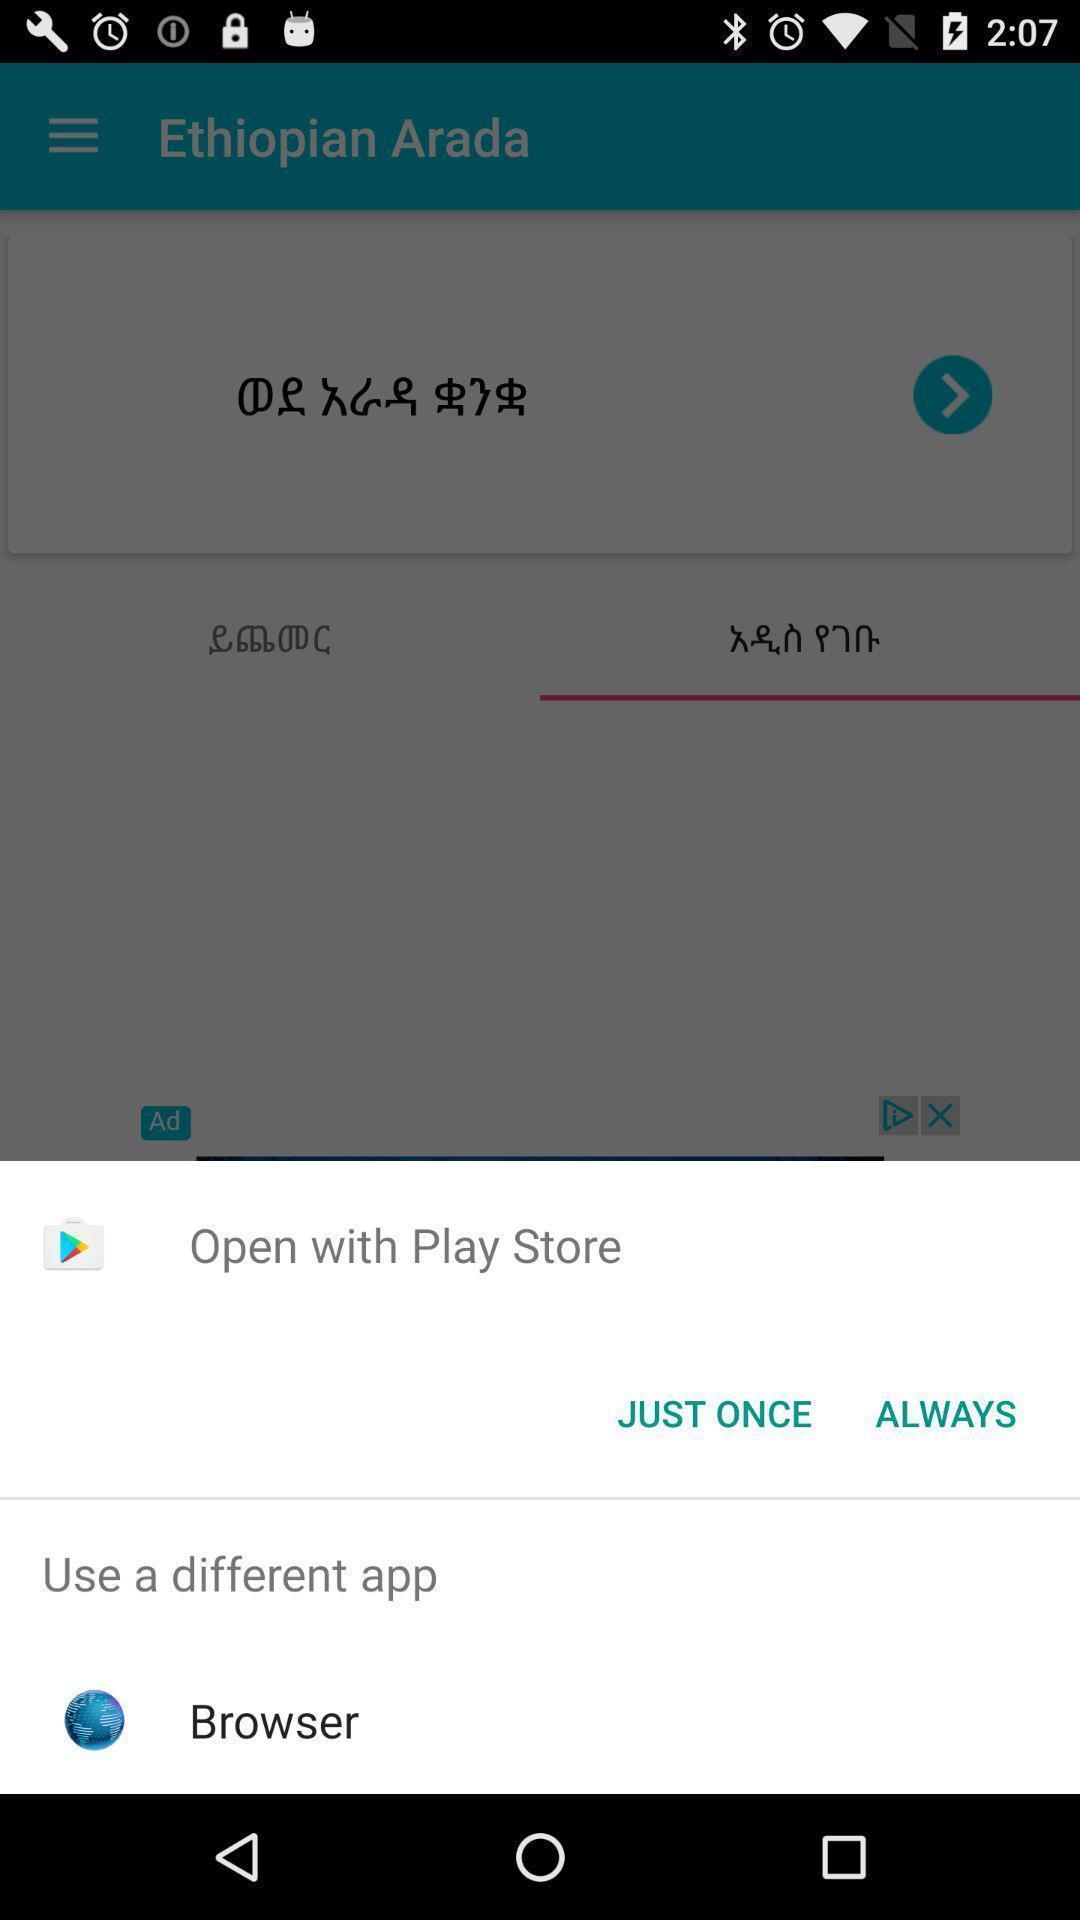Please provide a description for this image. Widget showing different browsing options. 